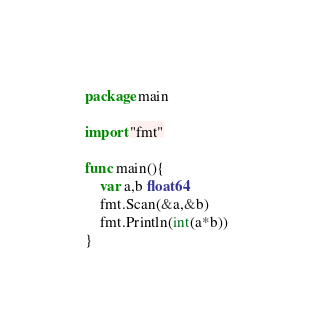<code> <loc_0><loc_0><loc_500><loc_500><_Go_>package main

import "fmt"

func main(){
	var a,b float64
	fmt.Scan(&a,&b)
	fmt.Println(int(a*b))
}
</code> 